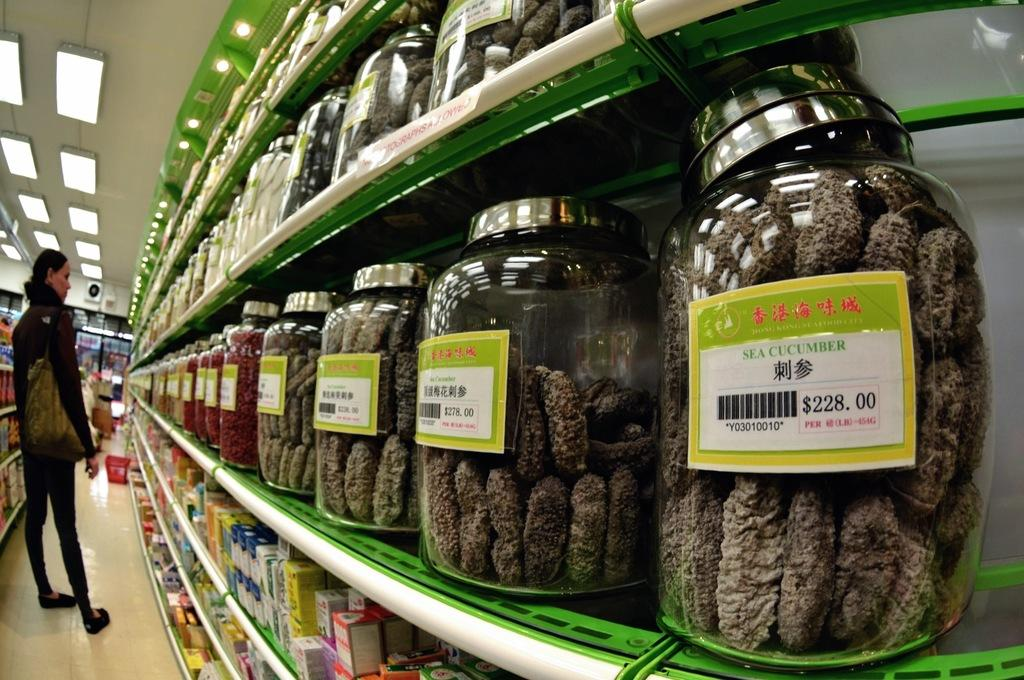<image>
Create a compact narrative representing the image presented. A store with sea cucumber jars lined up 